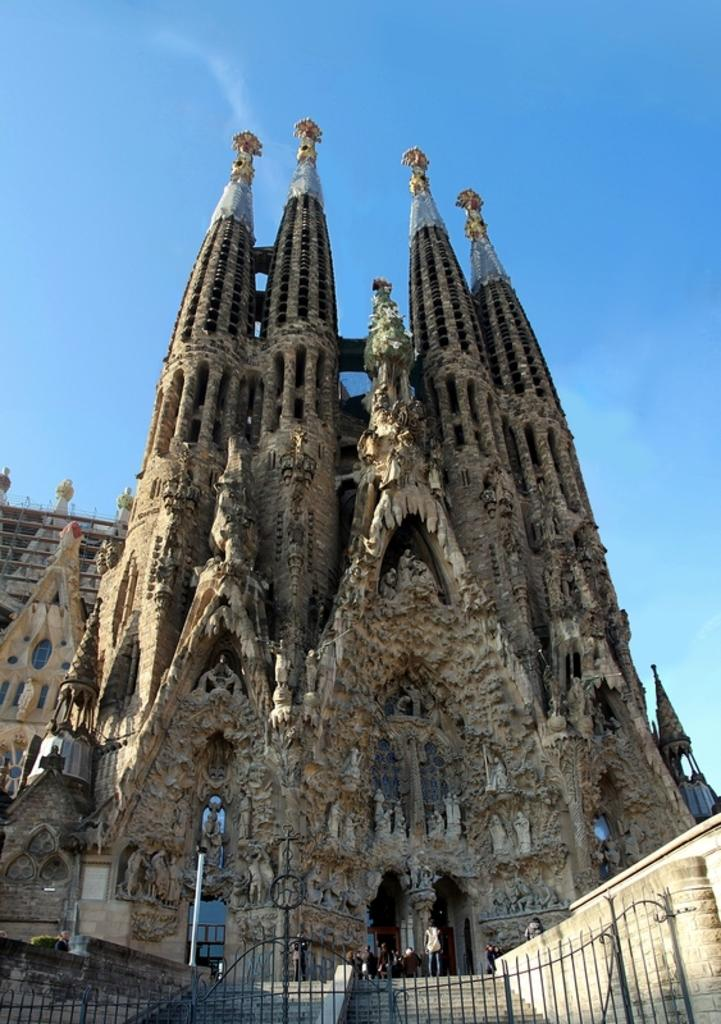What type of structure is in the image? There is a metal gate in the image. What architectural feature can be seen in the image? There are stairs in the image. What can be seen in the background of the image? There are people and a building in the background of the image, as well as the sky. What type of straw is being used by the men in the image? There are no men or straws present in the image. 